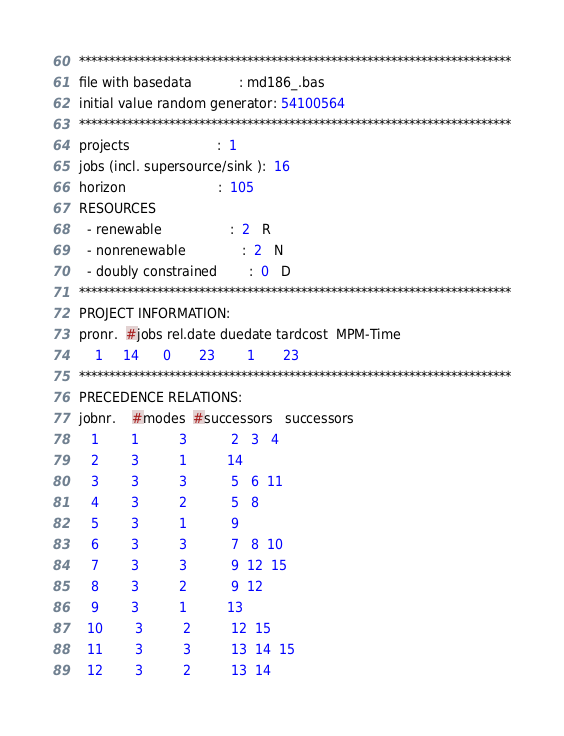<code> <loc_0><loc_0><loc_500><loc_500><_ObjectiveC_>************************************************************************
file with basedata            : md186_.bas
initial value random generator: 54100564
************************************************************************
projects                      :  1
jobs (incl. supersource/sink ):  16
horizon                       :  105
RESOURCES
  - renewable                 :  2   R
  - nonrenewable              :  2   N
  - doubly constrained        :  0   D
************************************************************************
PROJECT INFORMATION:
pronr.  #jobs rel.date duedate tardcost  MPM-Time
    1     14      0       23        1       23
************************************************************************
PRECEDENCE RELATIONS:
jobnr.    #modes  #successors   successors
   1        1          3           2   3   4
   2        3          1          14
   3        3          3           5   6  11
   4        3          2           5   8
   5        3          1           9
   6        3          3           7   8  10
   7        3          3           9  12  15
   8        3          2           9  12
   9        3          1          13
  10        3          2          12  15
  11        3          3          13  14  15
  12        3          2          13  14</code> 